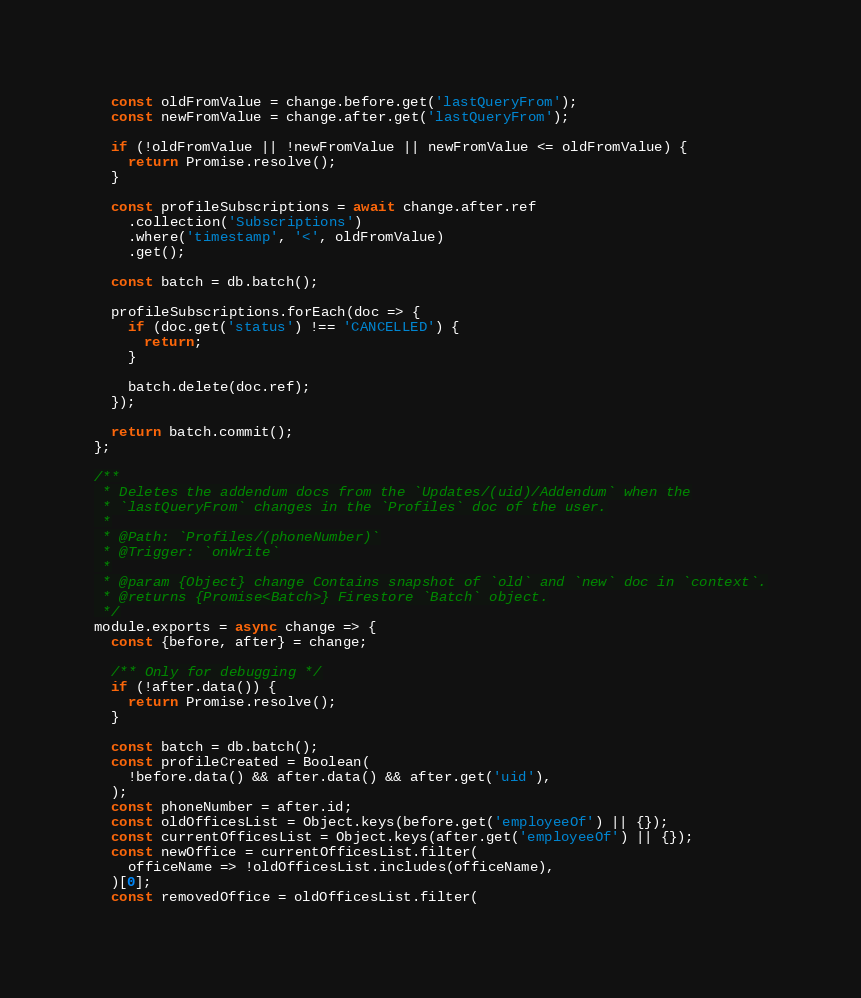<code> <loc_0><loc_0><loc_500><loc_500><_JavaScript_>  const oldFromValue = change.before.get('lastQueryFrom');
  const newFromValue = change.after.get('lastQueryFrom');

  if (!oldFromValue || !newFromValue || newFromValue <= oldFromValue) {
    return Promise.resolve();
  }

  const profileSubscriptions = await change.after.ref
    .collection('Subscriptions')
    .where('timestamp', '<', oldFromValue)
    .get();

  const batch = db.batch();

  profileSubscriptions.forEach(doc => {
    if (doc.get('status') !== 'CANCELLED') {
      return;
    }

    batch.delete(doc.ref);
  });

  return batch.commit();
};

/**
 * Deletes the addendum docs from the `Updates/(uid)/Addendum` when the
 * `lastQueryFrom` changes in the `Profiles` doc of the user.
 *
 * @Path: `Profiles/(phoneNumber)`
 * @Trigger: `onWrite`
 *
 * @param {Object} change Contains snapshot of `old` and `new` doc in `context`.
 * @returns {Promise<Batch>} Firestore `Batch` object.
 */
module.exports = async change => {
  const {before, after} = change;

  /** Only for debugging */
  if (!after.data()) {
    return Promise.resolve();
  }

  const batch = db.batch();
  const profileCreated = Boolean(
    !before.data() && after.data() && after.get('uid'),
  );
  const phoneNumber = after.id;
  const oldOfficesList = Object.keys(before.get('employeeOf') || {});
  const currentOfficesList = Object.keys(after.get('employeeOf') || {});
  const newOffice = currentOfficesList.filter(
    officeName => !oldOfficesList.includes(officeName),
  )[0];
  const removedOffice = oldOfficesList.filter(</code> 